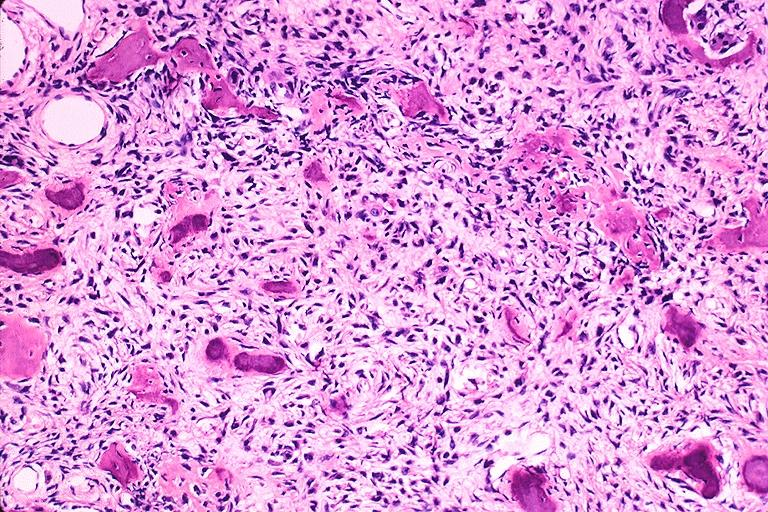s oral present?
Answer the question using a single word or phrase. Yes 